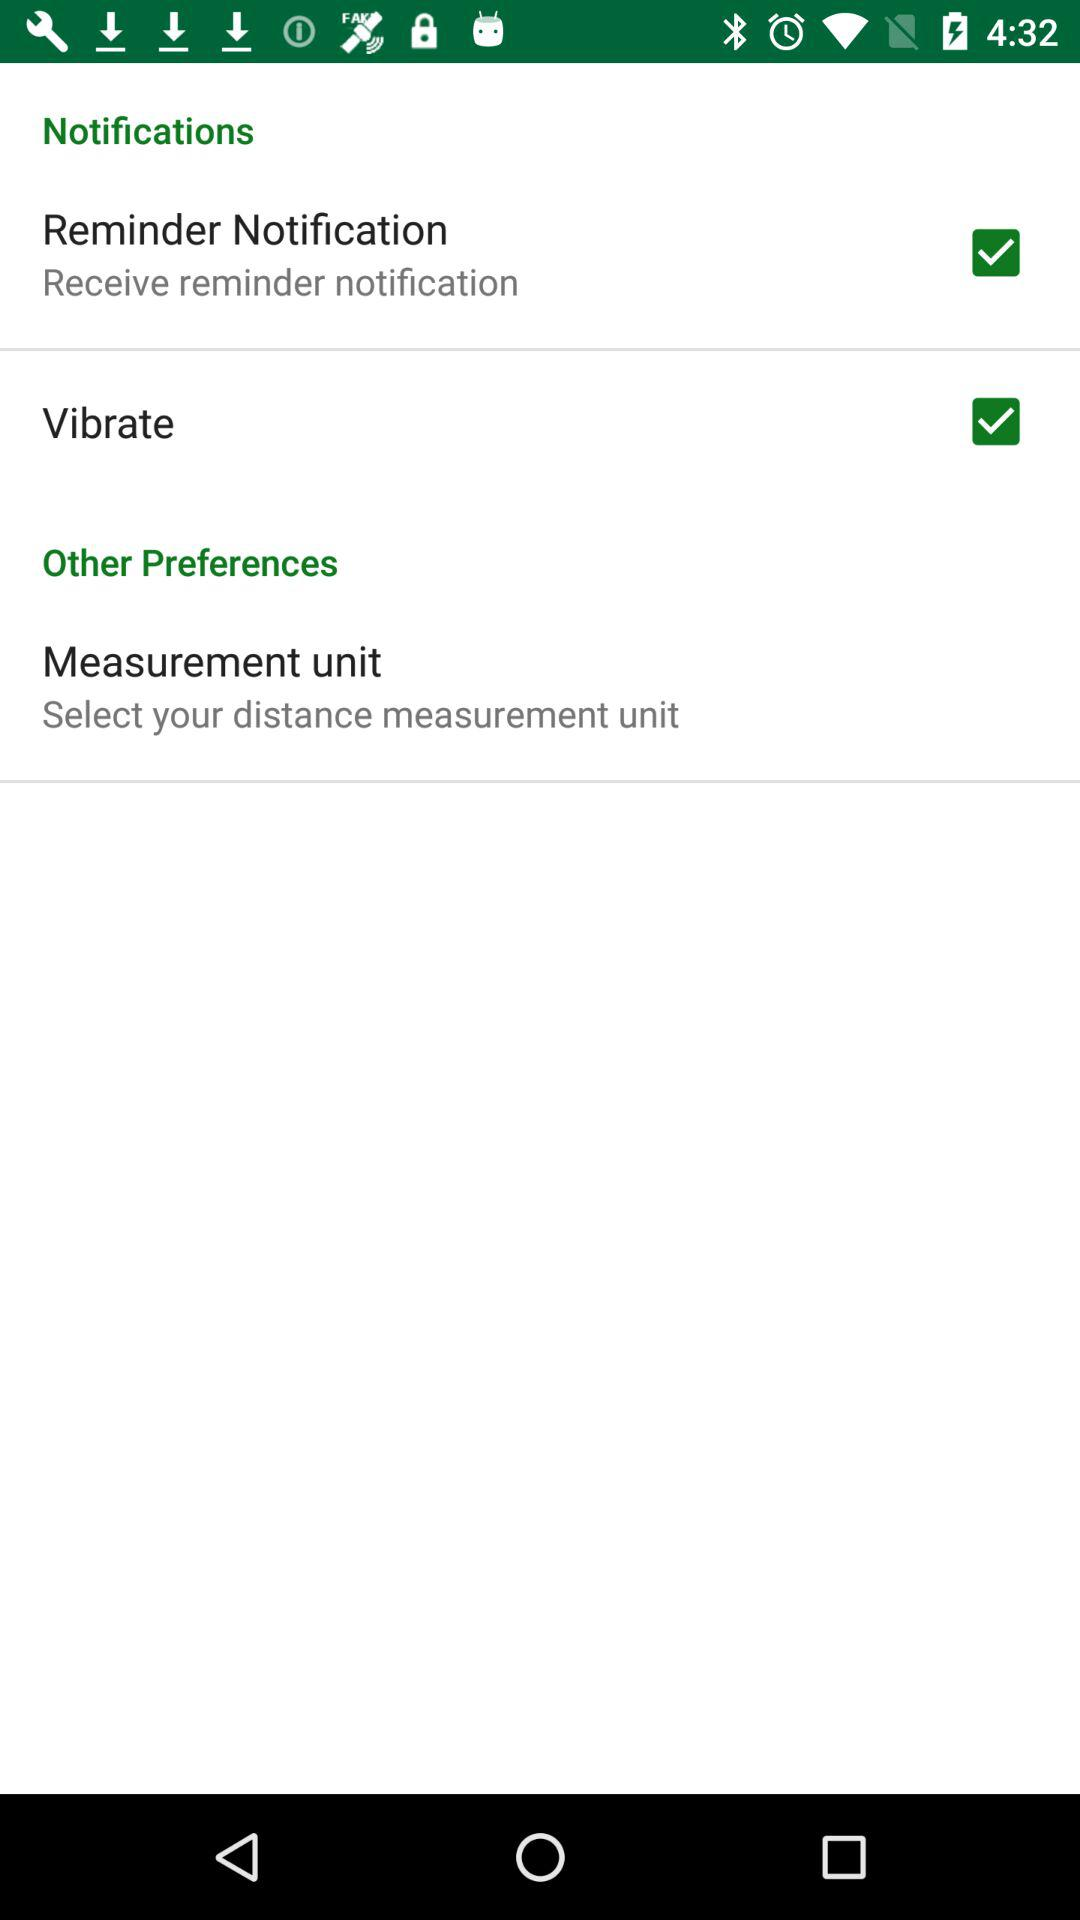What is the status of "Vibrate"? The status of "Vibrate" is "on". 